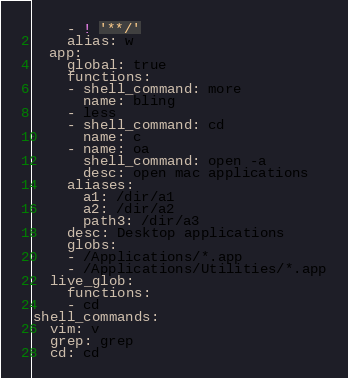<code> <loc_0><loc_0><loc_500><loc_500><_YAML_>    - ! '**/'
    alias: w
  app:
    global: true
    functions:
    - shell_command: more
      name: bling
    - less
    - shell_command: cd
      name: c
    - name: oa
      shell_command: open -a
      desc: open mac applications
    aliases:
      a1: /dir/a1
      a2: /dir/a2
      path3: /dir/a3
    desc: Desktop applications
    globs:
    - /Applications/*.app
    - /Applications/Utilities/*.app
  live_glob:
    functions:
    - cd
shell_commands:
  vim: v
  grep: grep
  cd: cd
</code> 